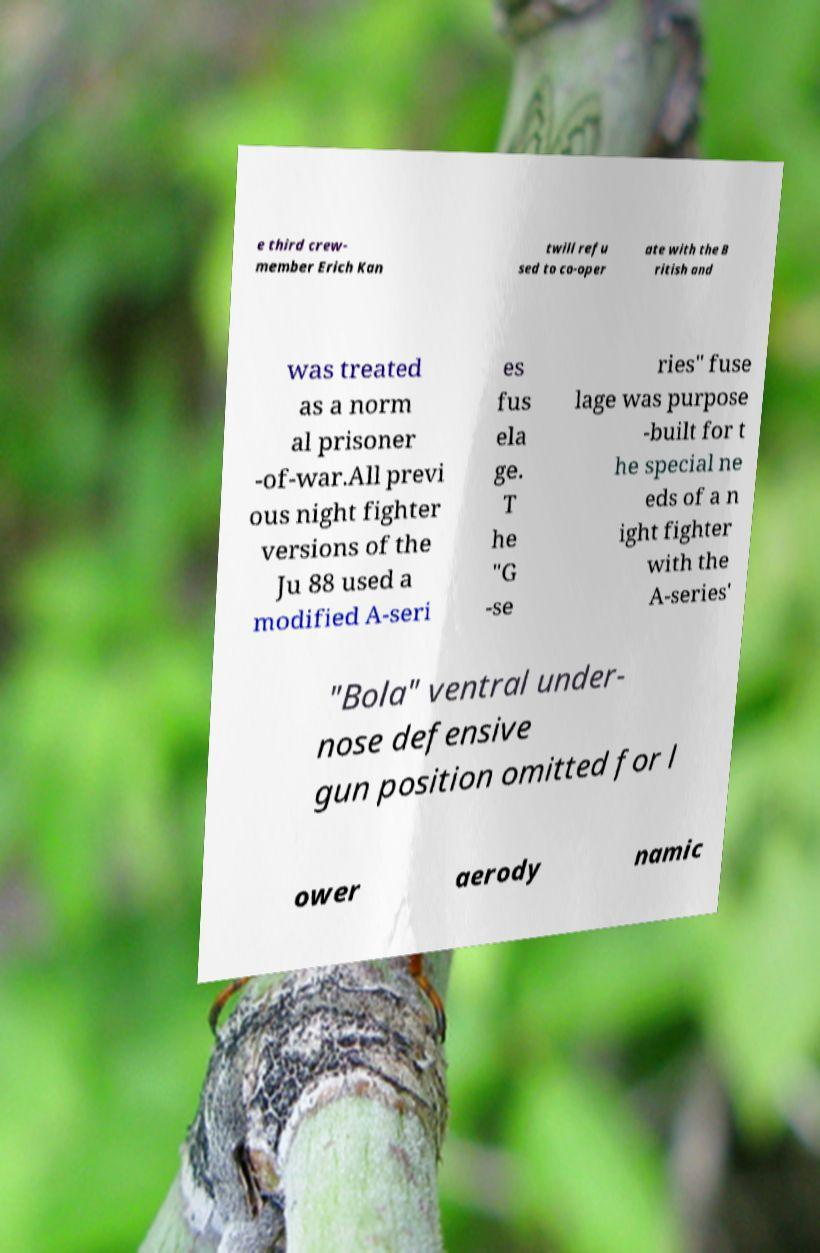Can you accurately transcribe the text from the provided image for me? e third crew- member Erich Kan twill refu sed to co-oper ate with the B ritish and was treated as a norm al prisoner -of-war.All previ ous night fighter versions of the Ju 88 used a modified A-seri es fus ela ge. T he "G -se ries" fuse lage was purpose -built for t he special ne eds of a n ight fighter with the A-series' "Bola" ventral under- nose defensive gun position omitted for l ower aerody namic 